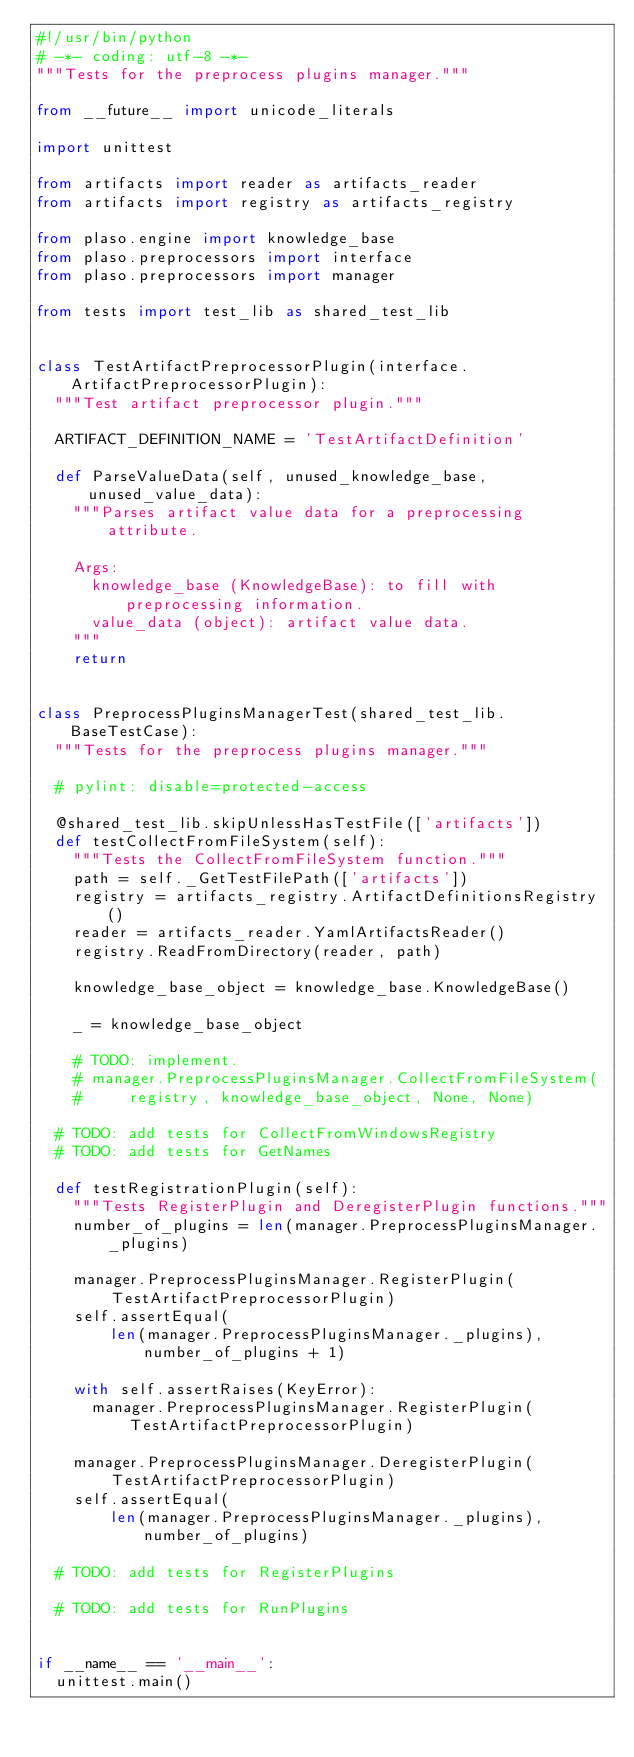<code> <loc_0><loc_0><loc_500><loc_500><_Python_>#!/usr/bin/python
# -*- coding: utf-8 -*-
"""Tests for the preprocess plugins manager."""

from __future__ import unicode_literals

import unittest

from artifacts import reader as artifacts_reader
from artifacts import registry as artifacts_registry

from plaso.engine import knowledge_base
from plaso.preprocessors import interface
from plaso.preprocessors import manager

from tests import test_lib as shared_test_lib


class TestArtifactPreprocessorPlugin(interface.ArtifactPreprocessorPlugin):
  """Test artifact preprocessor plugin."""

  ARTIFACT_DEFINITION_NAME = 'TestArtifactDefinition'

  def ParseValueData(self, unused_knowledge_base, unused_value_data):
    """Parses artifact value data for a preprocessing attribute.

    Args:
      knowledge_base (KnowledgeBase): to fill with preprocessing information.
      value_data (object): artifact value data.
    """
    return


class PreprocessPluginsManagerTest(shared_test_lib.BaseTestCase):
  """Tests for the preprocess plugins manager."""

  # pylint: disable=protected-access

  @shared_test_lib.skipUnlessHasTestFile(['artifacts'])
  def testCollectFromFileSystem(self):
    """Tests the CollectFromFileSystem function."""
    path = self._GetTestFilePath(['artifacts'])
    registry = artifacts_registry.ArtifactDefinitionsRegistry()
    reader = artifacts_reader.YamlArtifactsReader()
    registry.ReadFromDirectory(reader, path)

    knowledge_base_object = knowledge_base.KnowledgeBase()

    _ = knowledge_base_object

    # TODO: implement.
    # manager.PreprocessPluginsManager.CollectFromFileSystem(
    #     registry, knowledge_base_object, None, None)

  # TODO: add tests for CollectFromWindowsRegistry
  # TODO: add tests for GetNames

  def testRegistrationPlugin(self):
    """Tests RegisterPlugin and DeregisterPlugin functions."""
    number_of_plugins = len(manager.PreprocessPluginsManager._plugins)

    manager.PreprocessPluginsManager.RegisterPlugin(
        TestArtifactPreprocessorPlugin)
    self.assertEqual(
        len(manager.PreprocessPluginsManager._plugins), number_of_plugins + 1)

    with self.assertRaises(KeyError):
      manager.PreprocessPluginsManager.RegisterPlugin(
          TestArtifactPreprocessorPlugin)

    manager.PreprocessPluginsManager.DeregisterPlugin(
        TestArtifactPreprocessorPlugin)
    self.assertEqual(
        len(manager.PreprocessPluginsManager._plugins), number_of_plugins)

  # TODO: add tests for RegisterPlugins

  # TODO: add tests for RunPlugins


if __name__ == '__main__':
  unittest.main()
</code> 